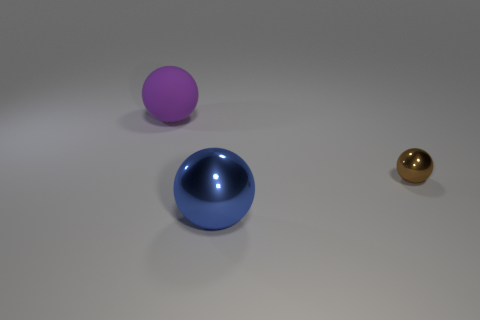Does the big thing that is in front of the big purple rubber object have the same material as the thing that is behind the brown thing?
Offer a very short reply. No. There is a brown thing that is the same material as the blue ball; what is its shape?
Provide a succinct answer. Sphere. Is there any other thing of the same color as the matte thing?
Your answer should be compact. No. What number of small brown shiny things are there?
Give a very brief answer. 1. What is the material of the big sphere that is in front of the ball behind the small sphere?
Offer a terse response. Metal. What color is the sphere in front of the shiny sphere that is behind the big object that is in front of the big matte thing?
Ensure brevity in your answer.  Blue. Do the large shiny object and the tiny metal thing have the same color?
Your response must be concise. No. What number of other brown spheres are the same size as the matte ball?
Make the answer very short. 0. Are there more purple spheres that are left of the matte thing than big purple matte things on the right side of the small brown metal object?
Your answer should be compact. No. What color is the big thing right of the big object that is behind the brown ball?
Your response must be concise. Blue. 